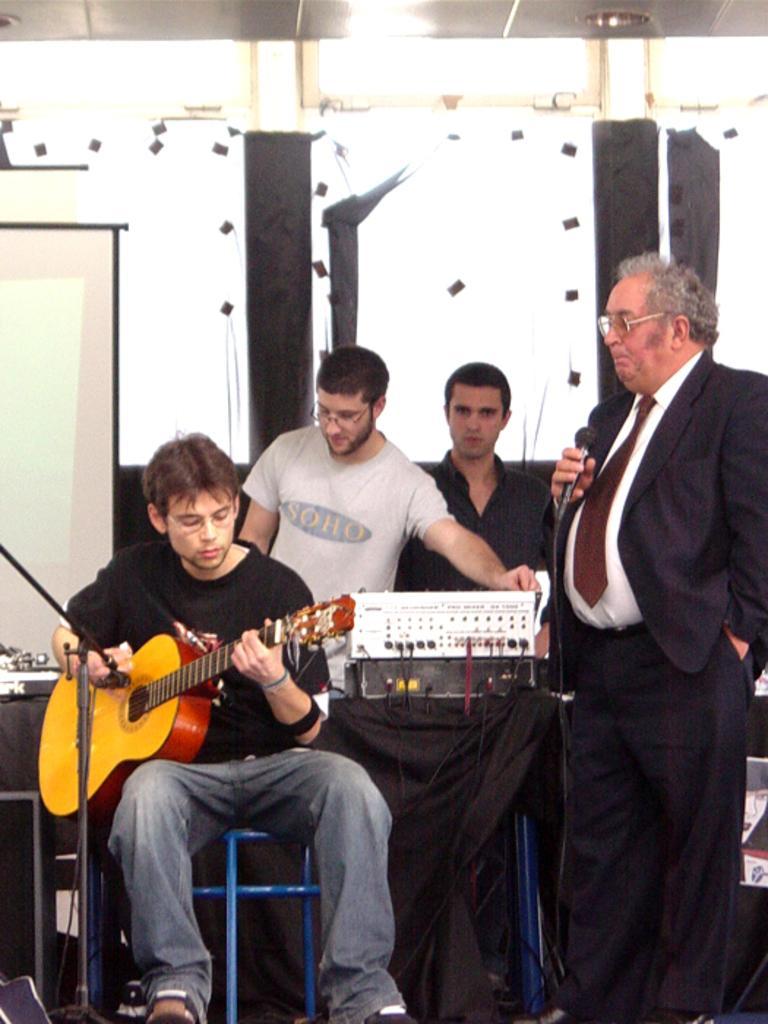In one or two sentences, can you explain what this image depicts? On the left a man is sitting and playing the guitar behind him there are two men standing on the right man is standing and holding a microphone he wear a tie, shirt, coat. 